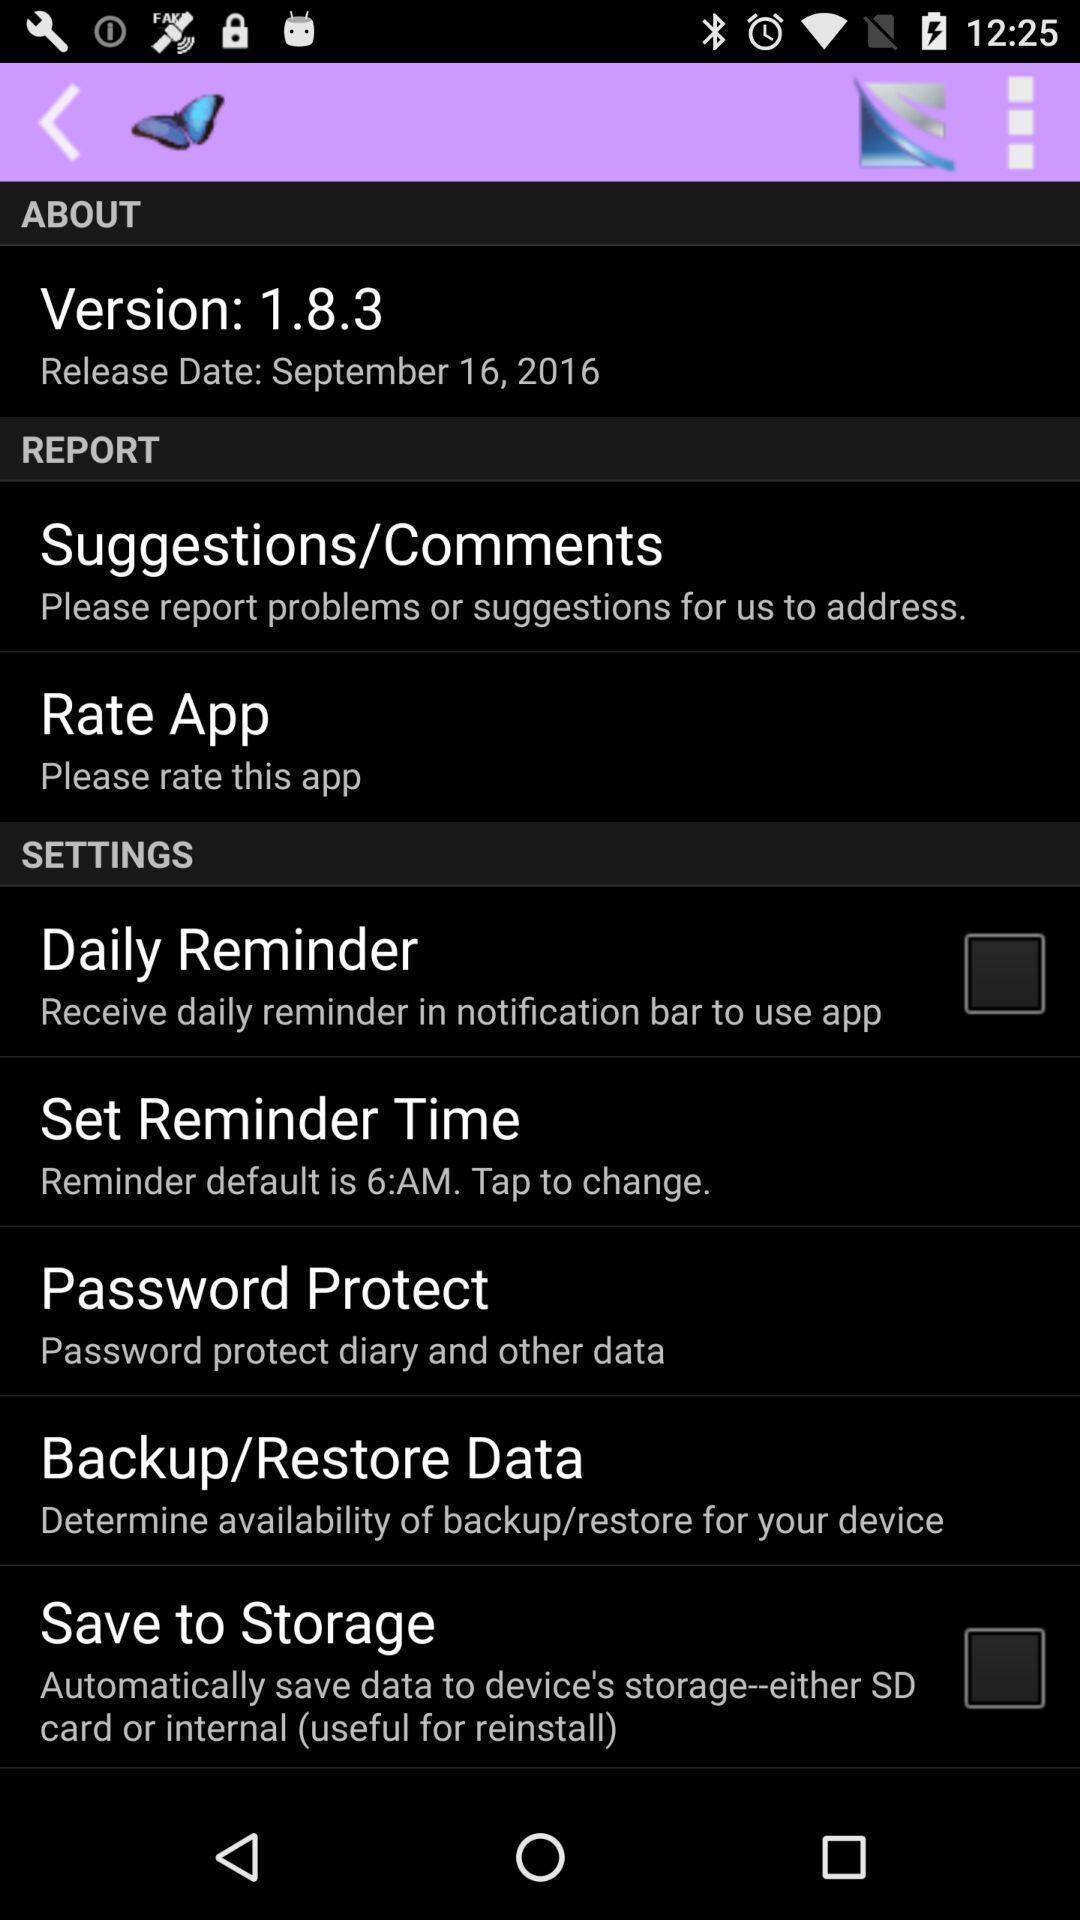Provide a detailed account of this screenshot. Page displaying with list of different settings with different aspects. 